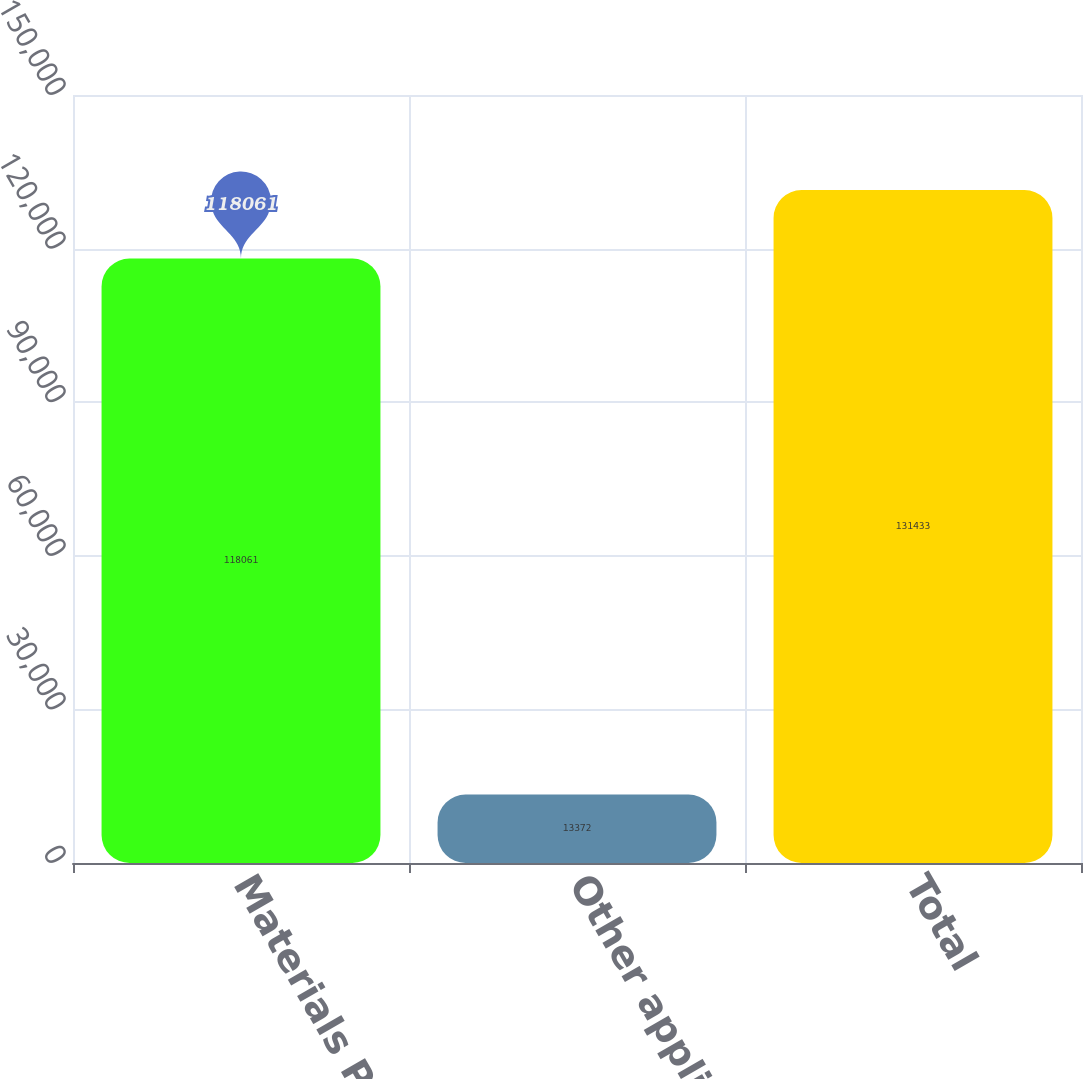Convert chart. <chart><loc_0><loc_0><loc_500><loc_500><bar_chart><fcel>Materials Processing<fcel>Other applications<fcel>Total<nl><fcel>118061<fcel>13372<fcel>131433<nl></chart> 